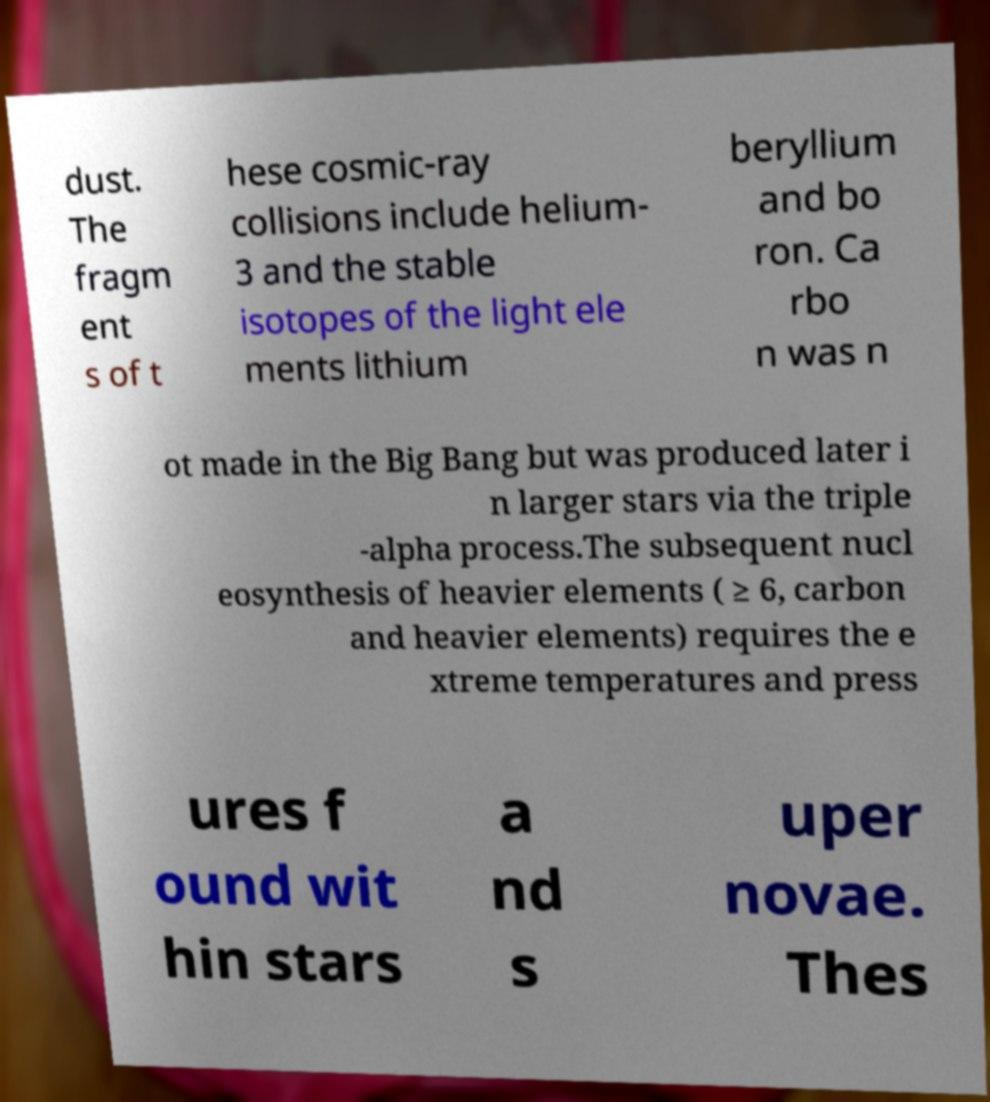Could you assist in decoding the text presented in this image and type it out clearly? dust. The fragm ent s of t hese cosmic-ray collisions include helium- 3 and the stable isotopes of the light ele ments lithium beryllium and bo ron. Ca rbo n was n ot made in the Big Bang but was produced later i n larger stars via the triple -alpha process.The subsequent nucl eosynthesis of heavier elements ( ≥ 6, carbon and heavier elements) requires the e xtreme temperatures and press ures f ound wit hin stars a nd s uper novae. Thes 